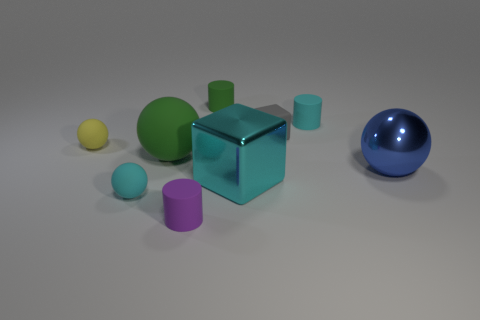Add 1 small blue rubber things. How many objects exist? 10 Subtract all spheres. How many objects are left? 5 Subtract 0 brown balls. How many objects are left? 9 Subtract all gray blocks. Subtract all tiny purple cylinders. How many objects are left? 7 Add 5 small gray things. How many small gray things are left? 6 Add 2 tiny purple rubber things. How many tiny purple rubber things exist? 3 